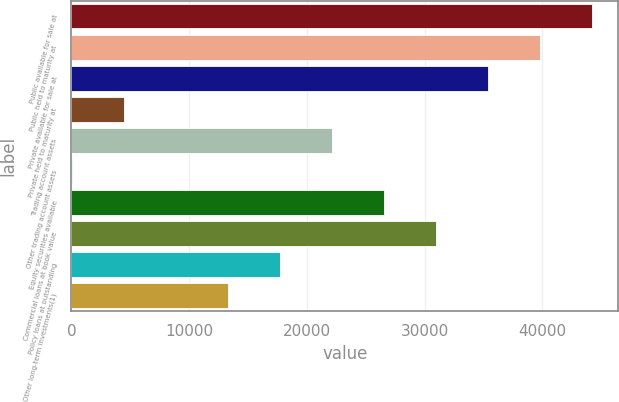<chart> <loc_0><loc_0><loc_500><loc_500><bar_chart><fcel>Public available for sale at<fcel>Public held to maturity at<fcel>Private available for sale at<fcel>Private held to maturity at<fcel>Trading account assets<fcel>Other trading account assets<fcel>Equity securities available<fcel>Commercial loans at book value<fcel>Policy loans at outstanding<fcel>Other long-term investments(1)<nl><fcel>44222<fcel>39802.4<fcel>35382.8<fcel>4445.6<fcel>22124<fcel>26<fcel>26543.6<fcel>30963.2<fcel>17704.4<fcel>13284.8<nl></chart> 